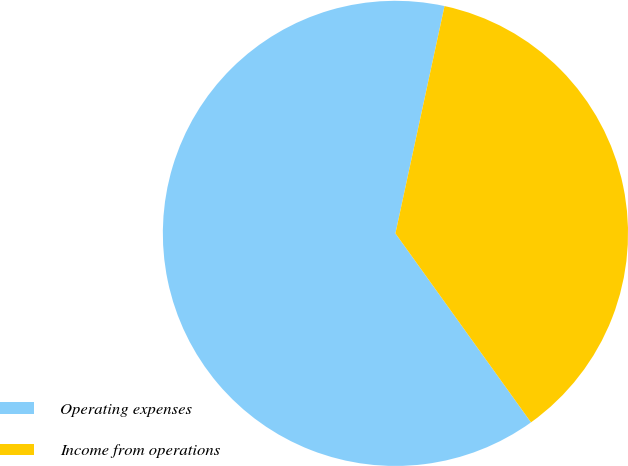<chart> <loc_0><loc_0><loc_500><loc_500><pie_chart><fcel>Operating expenses<fcel>Income from operations<nl><fcel>63.29%<fcel>36.71%<nl></chart> 